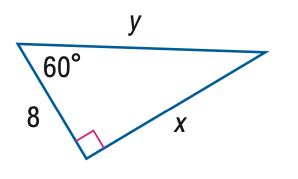Answer the mathemtical geometry problem and directly provide the correct option letter.
Question: Find y.
Choices: A: 8 B: 11.3 C: 13.9 D: 16 D 